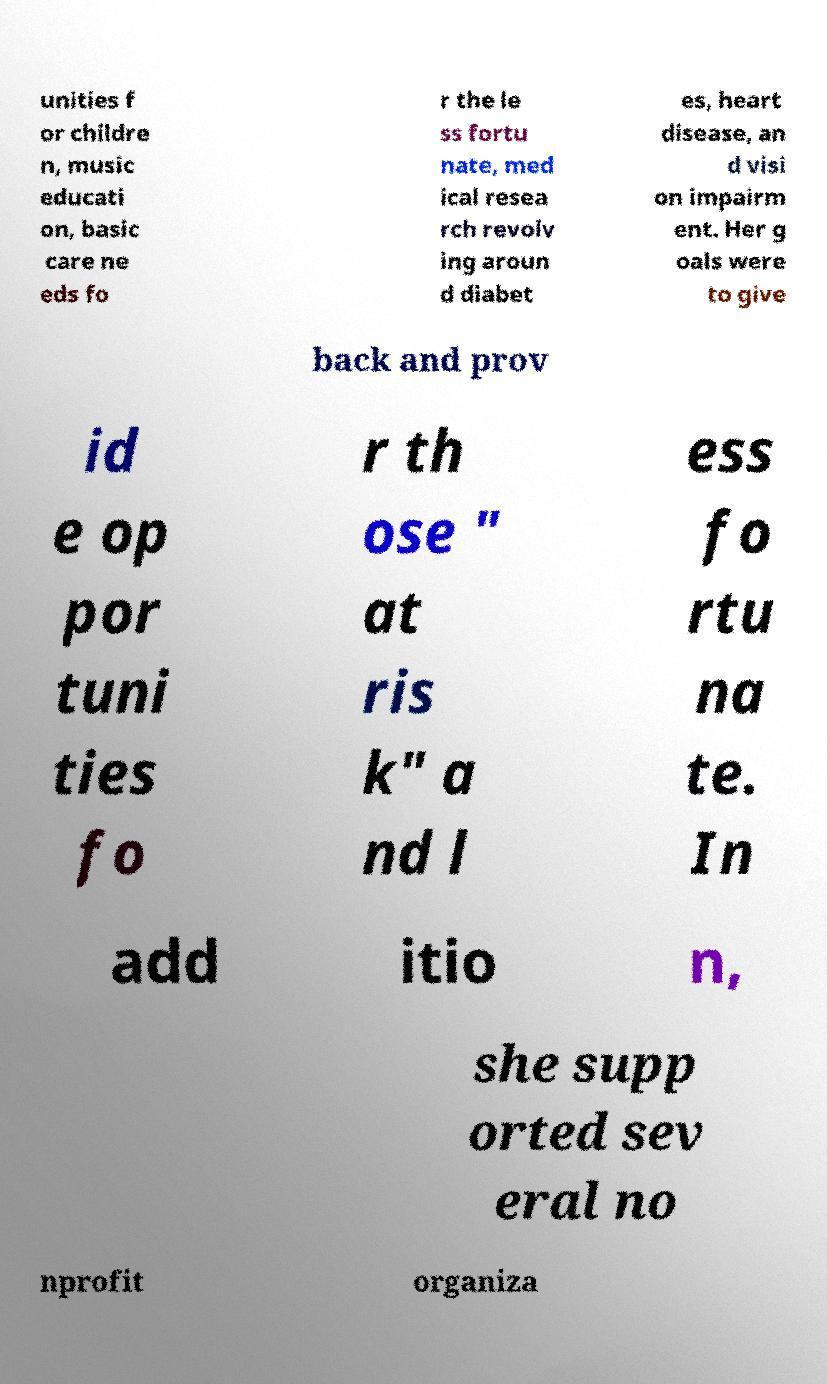There's text embedded in this image that I need extracted. Can you transcribe it verbatim? unities f or childre n, music educati on, basic care ne eds fo r the le ss fortu nate, med ical resea rch revolv ing aroun d diabet es, heart disease, an d visi on impairm ent. Her g oals were to give back and prov id e op por tuni ties fo r th ose " at ris k" a nd l ess fo rtu na te. In add itio n, she supp orted sev eral no nprofit organiza 